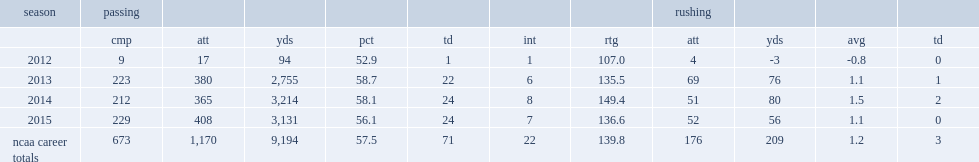How many passing yards did cook get in 2014? 3214.0. 